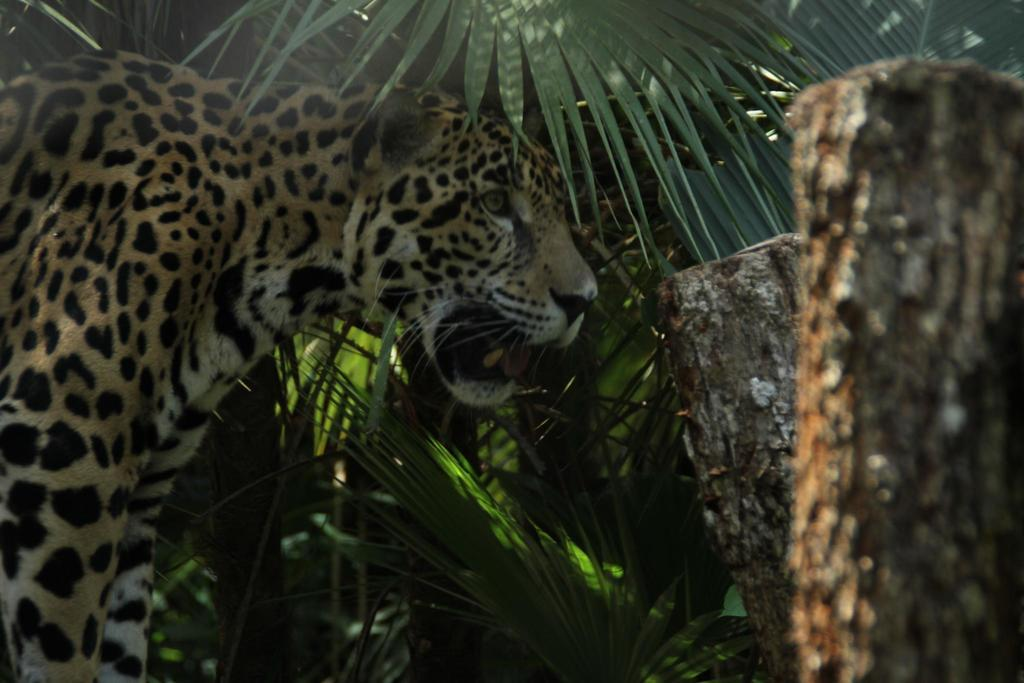What type of animal is in the image? There is a tiger in the image. What colors can be seen on the tiger? The tiger has black, brown, and white colors. What is in front of the tiger? There are wooden logs in front of the tiger. What can be seen in the background of the image? There are plants in the background of the image. How much money is the tiger holding in the image? There is no money present in the image; the tiger is not holding anything. Can you see any spiders on the tiger in the image? There are no spiders visible on the tiger in the image. 